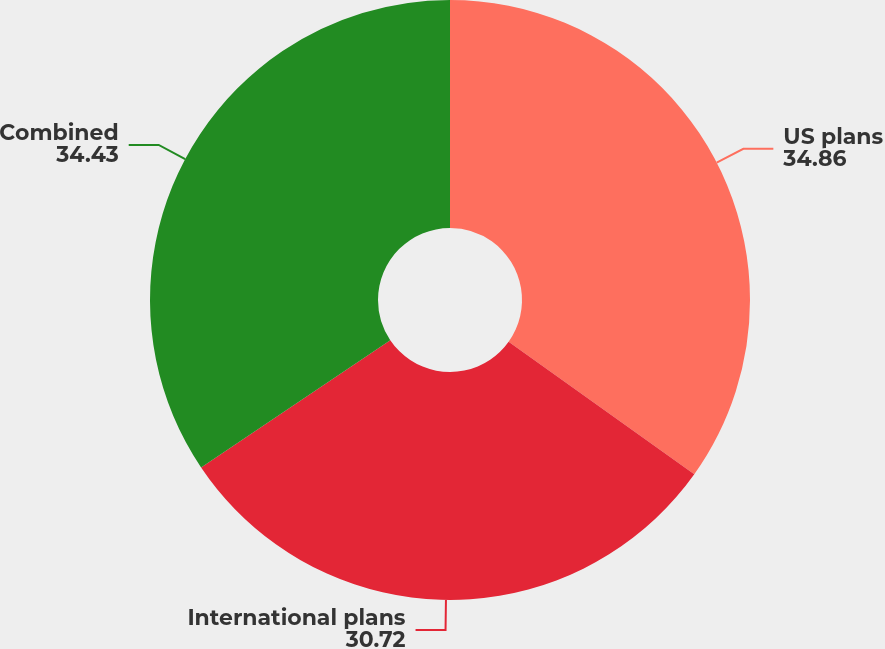Convert chart to OTSL. <chart><loc_0><loc_0><loc_500><loc_500><pie_chart><fcel>US plans<fcel>International plans<fcel>Combined<nl><fcel>34.86%<fcel>30.72%<fcel>34.43%<nl></chart> 